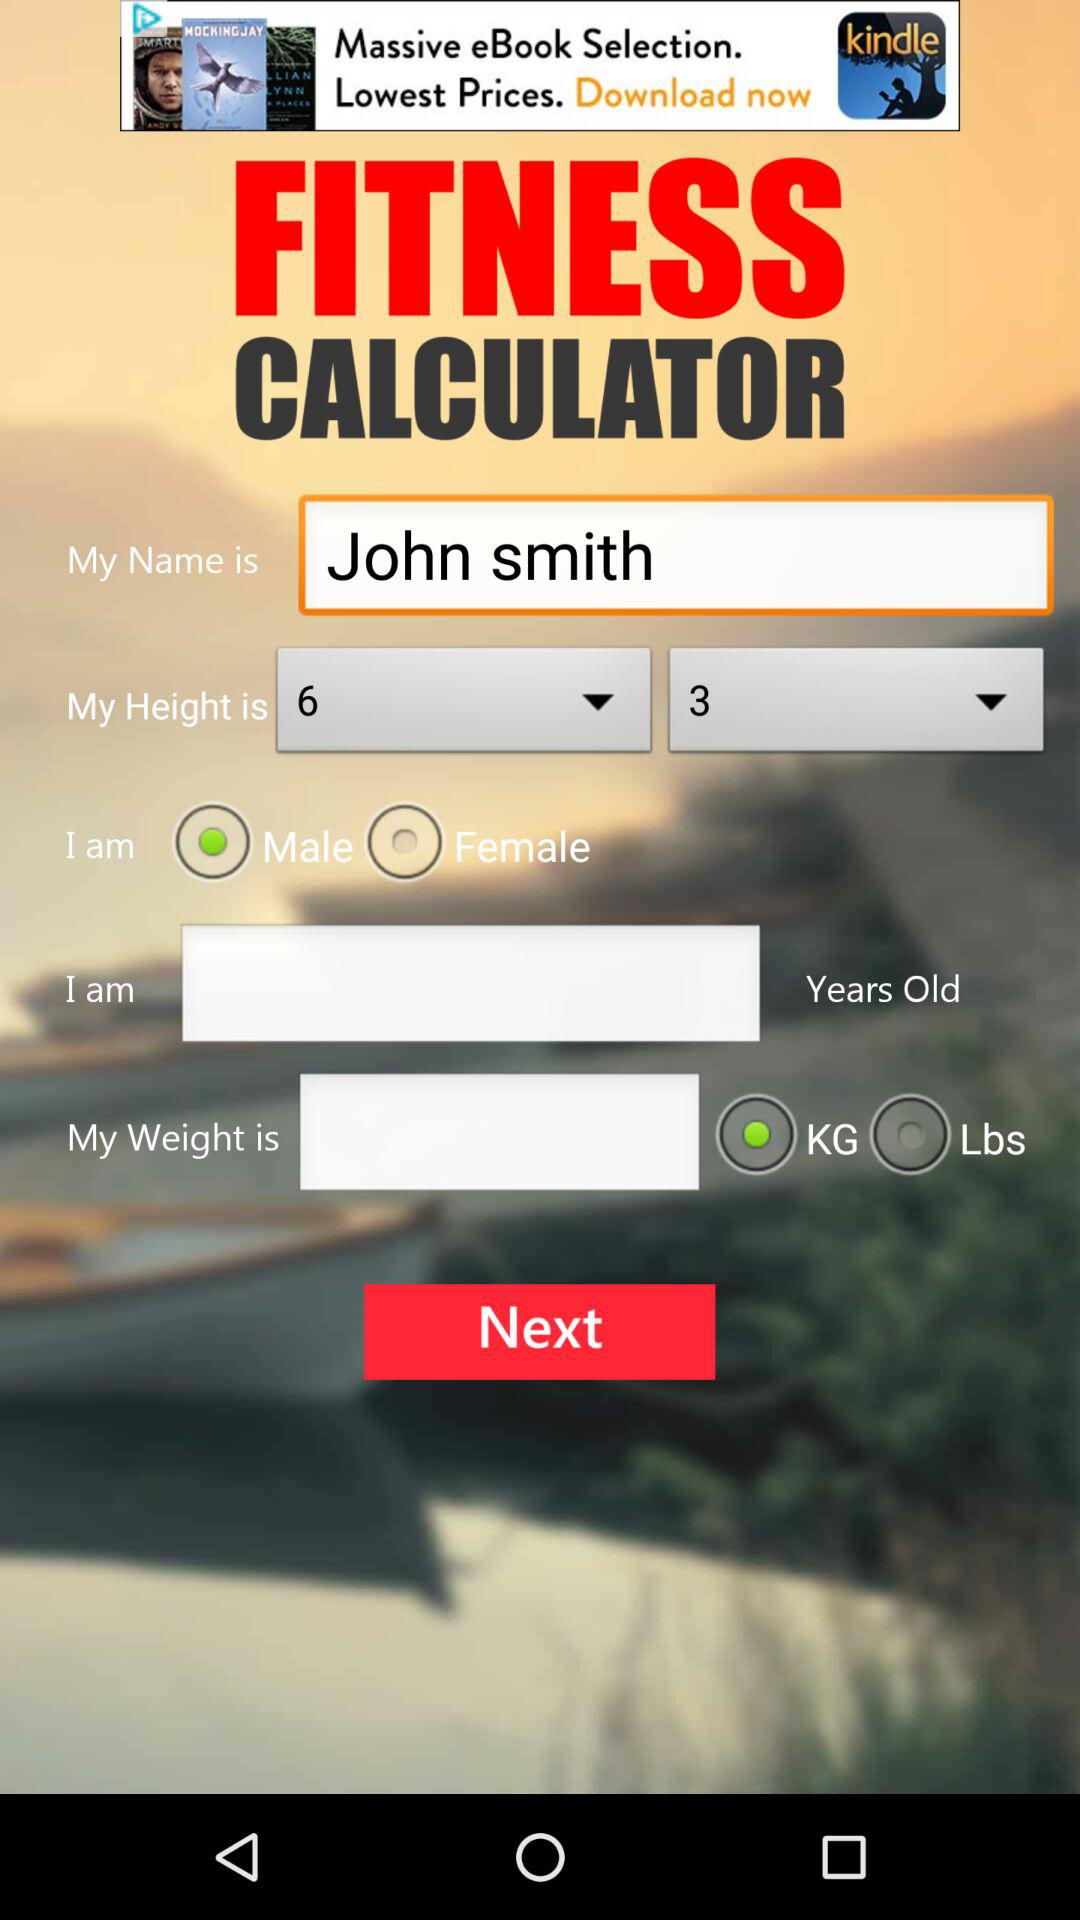What is the selected gender? The selected gender is male. 